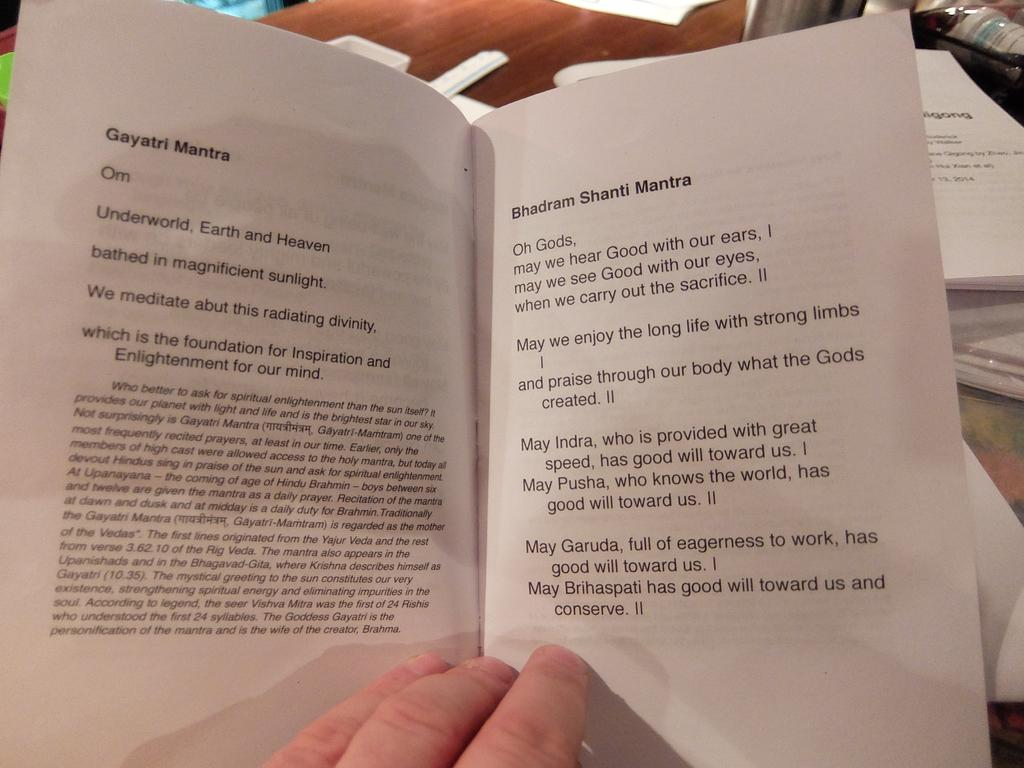<image>
Render a clear and concise summary of the photo. A person holding a medium sized book about Mantra. 